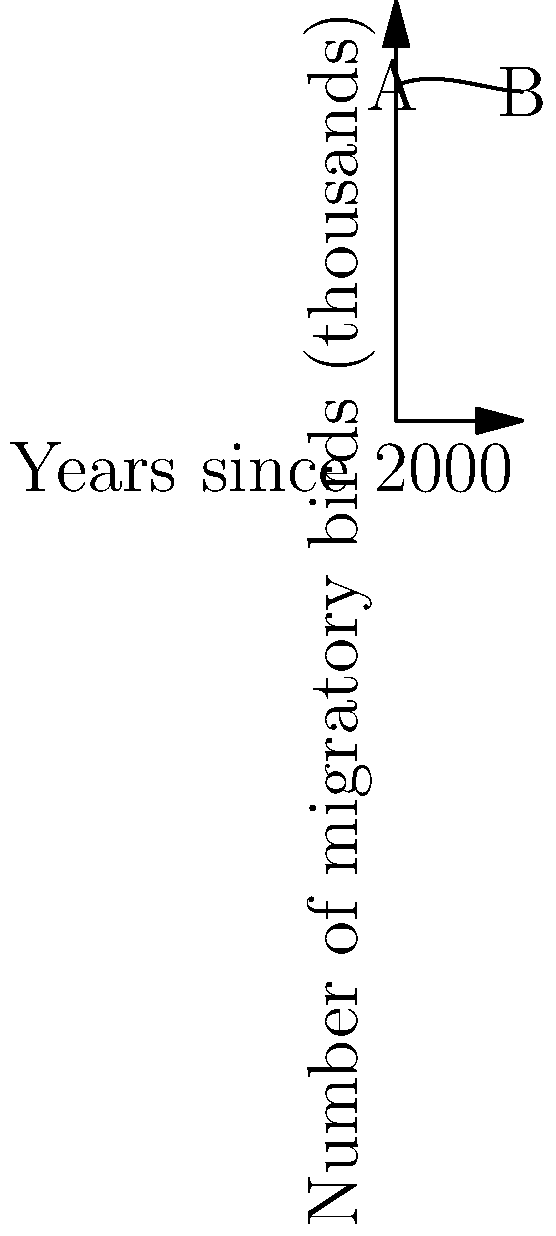The graph shows a polynomial model of the number of migratory birds (in thousands) observed in a specific conservation area over time. Point A represents the year 2000, and point B represents 2030. If this trend continues, approximately how many years after 2000 will the bird population reach its minimum before starting to increase again? To solve this problem, we need to follow these steps:

1) The polynomial appears to be a cubic function, which has the general form $f(x) = ax^3 + bx^2 + cx + d$.

2) The minimum point of a cubic function occurs where its derivative is zero. The derivative of a cubic function is a quadratic function.

3) For a quadratic function $g(x) = ax^2 + bx + c$, the x-coordinate of its vertex is given by $x = -b/(2a)$.

4) From the graph, we can estimate that the minimum occurs around 20 years after 2000.

5) To verify this, we could set up a system of equations using points from the graph and solve for the coefficients of the polynomial. However, for this question, a reasonable estimate based on the graph is sufficient.

6) The graph shows the population decreasing initially, reaching a minimum, and then starting to increase again. This minimum point occurs approximately 20 years after the starting point.
Answer: Approximately 20 years 